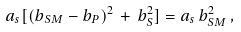<formula> <loc_0><loc_0><loc_500><loc_500>a _ { s } [ ( b _ { S M } - b _ { P } ) ^ { 2 } \, + \, b _ { S } ^ { 2 } ] = a _ { s } \, b _ { S M } ^ { 2 } \, ,</formula> 